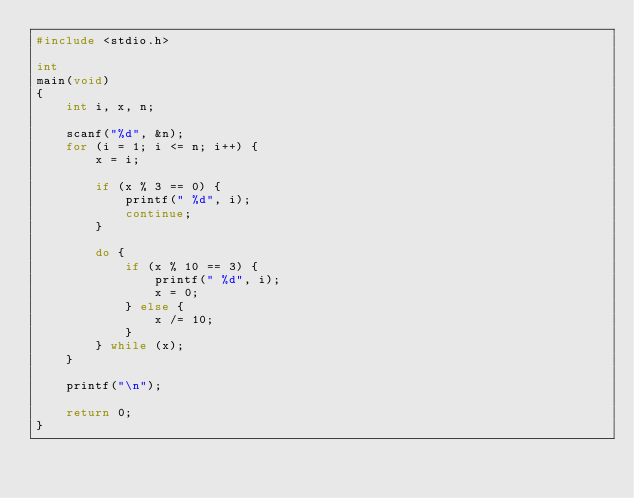Convert code to text. <code><loc_0><loc_0><loc_500><loc_500><_C_>#include <stdio.h>

int
main(void)
{
	int i, x, n;

	scanf("%d", &n);
	for (i = 1; i <= n; i++) {
		x = i;

		if (x % 3 == 0) {
			printf(" %d", i);
			continue;
		}

		do {
			if (x % 10 == 3) {
				printf(" %d", i);
				x = 0;
			} else {
				x /= 10;
			}
		} while (x);
	}

	printf("\n");

	return 0;
}

</code> 